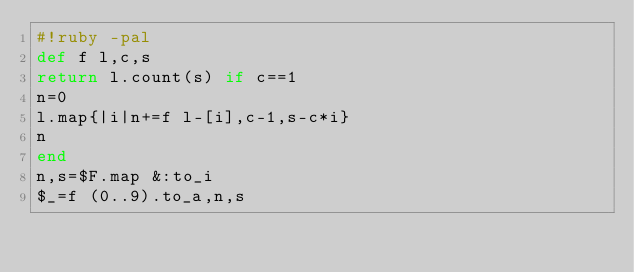<code> <loc_0><loc_0><loc_500><loc_500><_Ruby_>#!ruby -pal
def f l,c,s
return l.count(s) if c==1
n=0
l.map{|i|n+=f l-[i],c-1,s-c*i}
n
end
n,s=$F.map &:to_i
$_=f (0..9).to_a,n,s</code> 